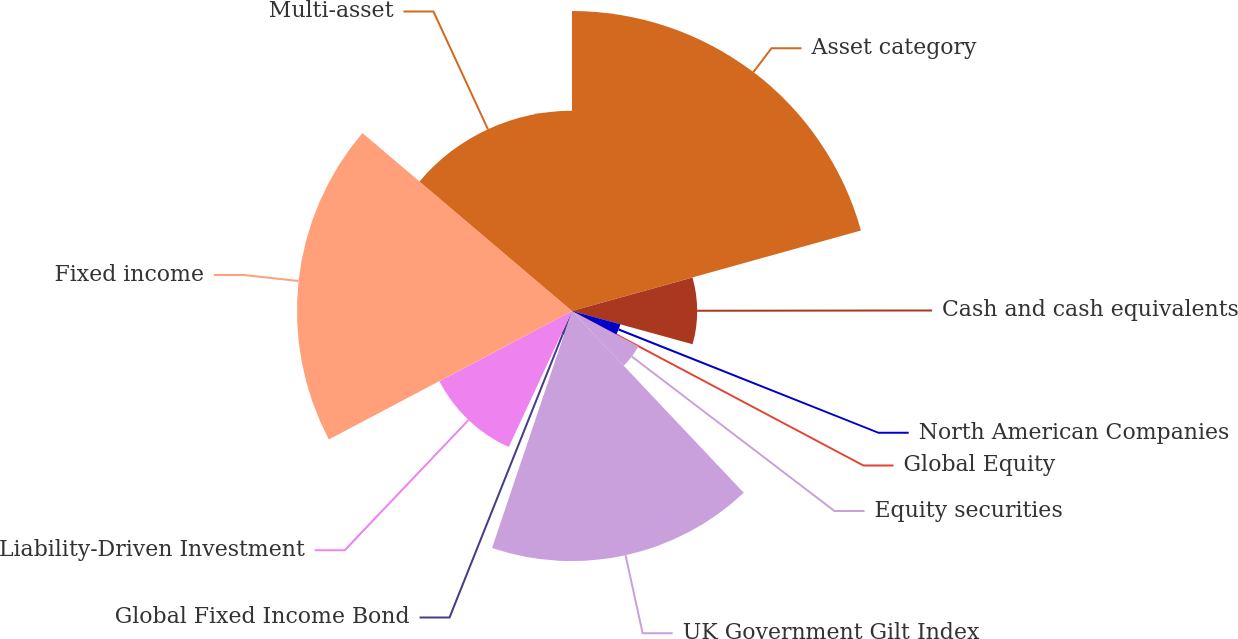Convert chart. <chart><loc_0><loc_0><loc_500><loc_500><pie_chart><fcel>Asset category<fcel>Cash and cash equivalents<fcel>North American Companies<fcel>Global Equity<fcel>Equity securities<fcel>UK Government Gilt Index<fcel>Global Fixed Income Bond<fcel>Liability-Driven Investment<fcel>Fixed income<fcel>Multi-asset<nl><fcel>20.67%<fcel>8.62%<fcel>3.46%<fcel>0.02%<fcel>5.18%<fcel>17.23%<fcel>1.74%<fcel>10.34%<fcel>18.95%<fcel>13.79%<nl></chart> 